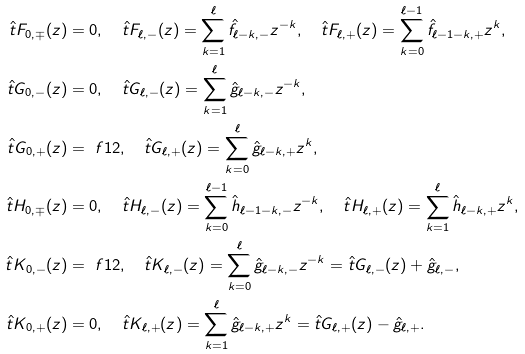<formula> <loc_0><loc_0><loc_500><loc_500>\hat { t } F _ { 0 , \mp } ( z ) & = 0 , \quad \hat { t } F _ { \ell , - } ( z ) = \sum _ { k = 1 } ^ { \ell } \hat { f } _ { \ell - k , - } z ^ { - k } , \quad \hat { t } F _ { \ell , + } ( z ) = \sum _ { k = 0 } ^ { \ell - 1 } \hat { f } _ { \ell - 1 - k , + } z ^ { k } , \\ \hat { t } G _ { 0 , - } ( z ) & = 0 , \quad \hat { t } G _ { \ell , - } ( z ) = \sum _ { k = 1 } ^ { \ell } \hat { g } _ { \ell - k , - } z ^ { - k } , \\ \hat { t } G _ { 0 , + } ( z ) & = \ f { 1 } { 2 } , \quad \hat { t } G _ { \ell , + } ( z ) = \sum _ { k = 0 } ^ { \ell } \hat { g } _ { \ell - k , + } z ^ { k } , \\ \hat { t } H _ { 0 , \mp } ( z ) & = 0 , \quad \hat { t } H _ { \ell , - } ( z ) = \sum _ { k = 0 } ^ { \ell - 1 } \hat { h } _ { \ell - 1 - k , - } z ^ { - k } , \quad \hat { t } H _ { \ell , + } ( z ) = \sum _ { k = 1 } ^ { \ell } \hat { h } _ { \ell - k , + } z ^ { k } , \\ \hat { t } K _ { 0 , - } ( z ) & = \ f { 1 } { 2 } , \quad \hat { t } K _ { \ell , - } ( z ) = \sum _ { k = 0 } ^ { \ell } \hat { g } _ { \ell - k , - } z ^ { - k } = \hat { t } G _ { \ell , - } ( z ) + \hat { g } _ { \ell , - } , \\ \hat { t } K _ { 0 , + } ( z ) & = 0 , \quad \hat { t } K _ { \ell , + } ( z ) = \sum _ { k = 1 } ^ { \ell } \hat { g } _ { \ell - k , + } z ^ { k } = \hat { t } G _ { \ell , + } ( z ) - \hat { g } _ { \ell , + } .</formula> 